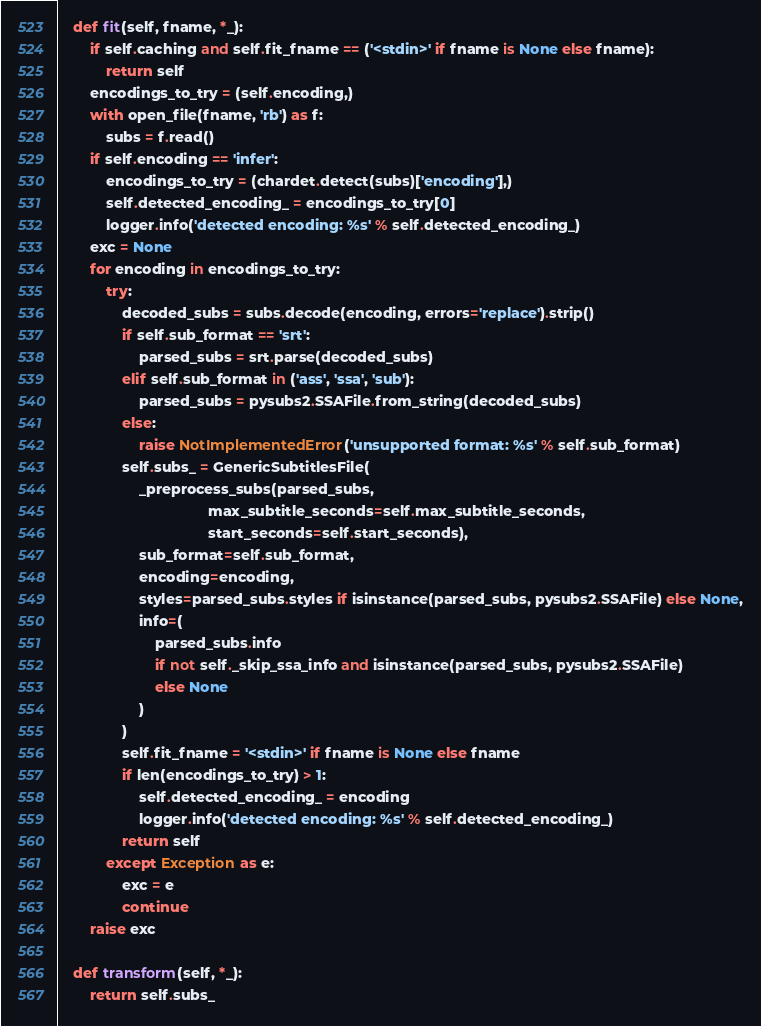Convert code to text. <code><loc_0><loc_0><loc_500><loc_500><_Python_>
    def fit(self, fname, *_):
        if self.caching and self.fit_fname == ('<stdin>' if fname is None else fname):
            return self
        encodings_to_try = (self.encoding,)
        with open_file(fname, 'rb') as f:
            subs = f.read()
        if self.encoding == 'infer':
            encodings_to_try = (chardet.detect(subs)['encoding'],)
            self.detected_encoding_ = encodings_to_try[0]
            logger.info('detected encoding: %s' % self.detected_encoding_)
        exc = None
        for encoding in encodings_to_try:
            try:
                decoded_subs = subs.decode(encoding, errors='replace').strip()
                if self.sub_format == 'srt':
                    parsed_subs = srt.parse(decoded_subs)
                elif self.sub_format in ('ass', 'ssa', 'sub'):
                    parsed_subs = pysubs2.SSAFile.from_string(decoded_subs)
                else:
                    raise NotImplementedError('unsupported format: %s' % self.sub_format)
                self.subs_ = GenericSubtitlesFile(
                    _preprocess_subs(parsed_subs,
                                     max_subtitle_seconds=self.max_subtitle_seconds,
                                     start_seconds=self.start_seconds),
                    sub_format=self.sub_format,
                    encoding=encoding,
                    styles=parsed_subs.styles if isinstance(parsed_subs, pysubs2.SSAFile) else None,
                    info=(
                        parsed_subs.info
                        if not self._skip_ssa_info and isinstance(parsed_subs, pysubs2.SSAFile)
                        else None
                    )
                )
                self.fit_fname = '<stdin>' if fname is None else fname
                if len(encodings_to_try) > 1:
                    self.detected_encoding_ = encoding
                    logger.info('detected encoding: %s' % self.detected_encoding_)
                return self
            except Exception as e:
                exc = e
                continue
        raise exc

    def transform(self, *_):
        return self.subs_
</code> 